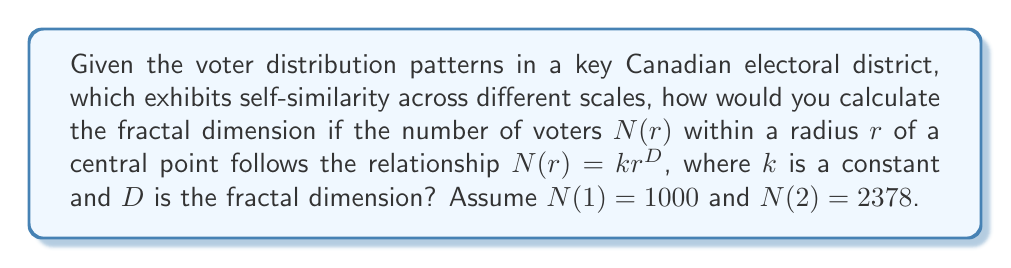Solve this math problem. To determine the fractal dimension $D$, we'll use the given relationship and the two data points:

1) We have $N(r) = kr^D$

2) For $r=1$: $N(1) = k(1)^D = k = 1000$

3) For $r=2$: $N(2) = k(2)^D = 2378$

4) Substituting $k=1000$ into the equation for $r=2$:

   $2378 = 1000(2)^D$

5) Dividing both sides by 1000:

   $2.378 = 2^D$

6) Taking the logarithm of both sides:

   $\log(2.378) = D \log(2)$

7) Solving for $D$:

   $D = \frac{\log(2.378)}{\log(2)}$

8) Calculate:

   $D = \frac{\log(2.378)}{\log(2)} \approx 1.25$

This fractal dimension suggests that the voter distribution has a more complex structure than a simple line (D=1) but is less space-filling than a plane (D=2), indicating clustering patterns in voter distribution.
Answer: $D \approx 1.25$ 